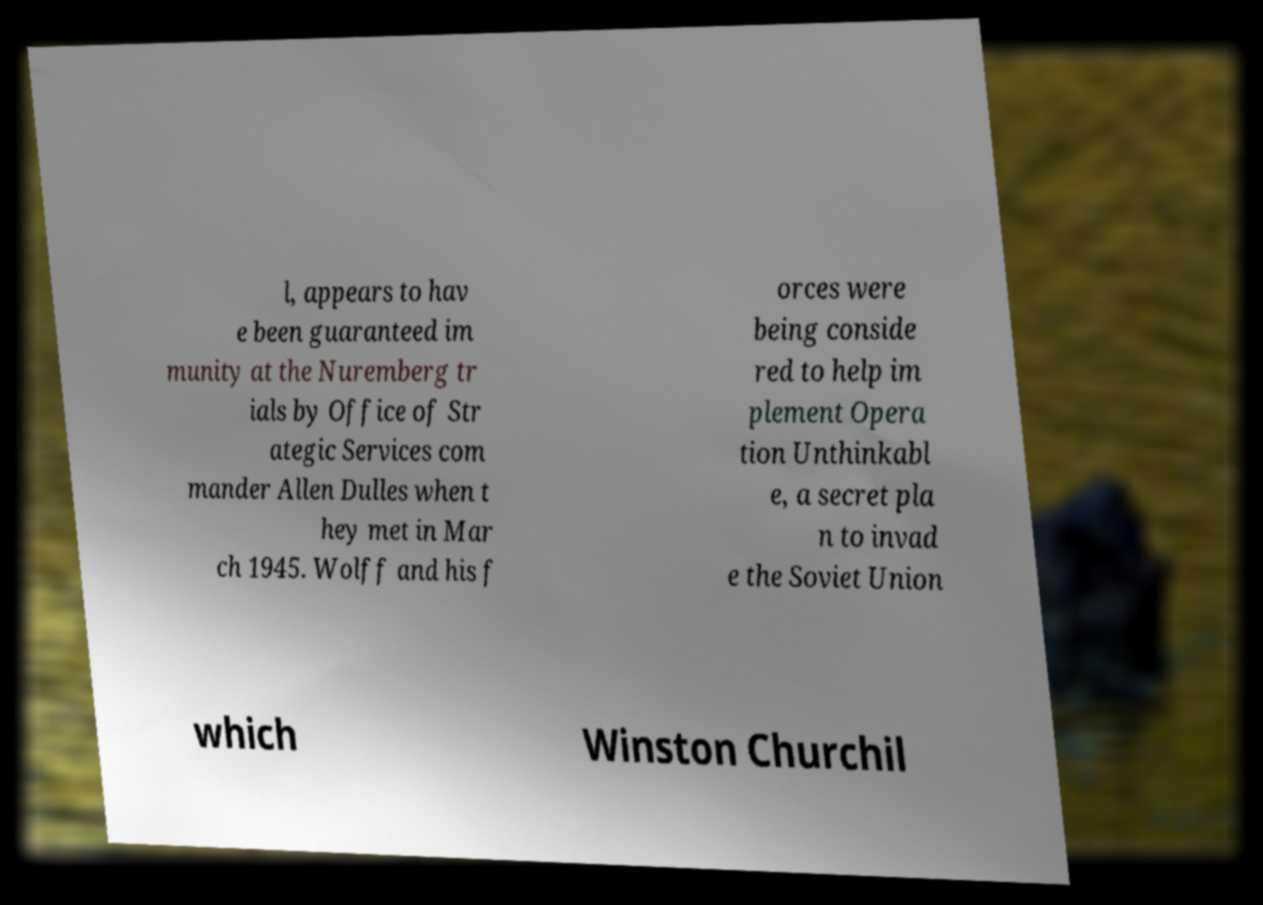Can you read and provide the text displayed in the image?This photo seems to have some interesting text. Can you extract and type it out for me? l, appears to hav e been guaranteed im munity at the Nuremberg tr ials by Office of Str ategic Services com mander Allen Dulles when t hey met in Mar ch 1945. Wolff and his f orces were being conside red to help im plement Opera tion Unthinkabl e, a secret pla n to invad e the Soviet Union which Winston Churchil 